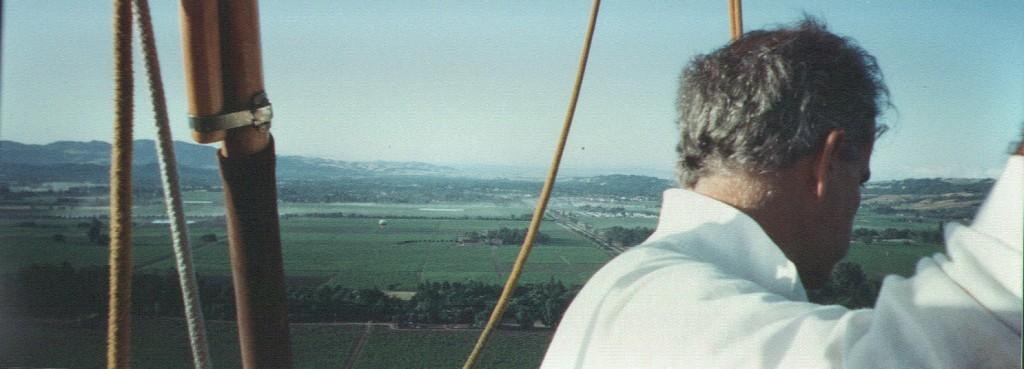What is the man in the image wearing? The man in the image is wearing a white shirt. What objects can be seen in the image besides the man? There are ropes and a wooden stick visible in the image. What type of landscape can be seen in the image? The image includes a view of fields, trees, and hills. How many brothers are visible in the image? There are no brothers present in the image. What type of calculator can be seen on the wooden stick? There is no calculator present in the image. 